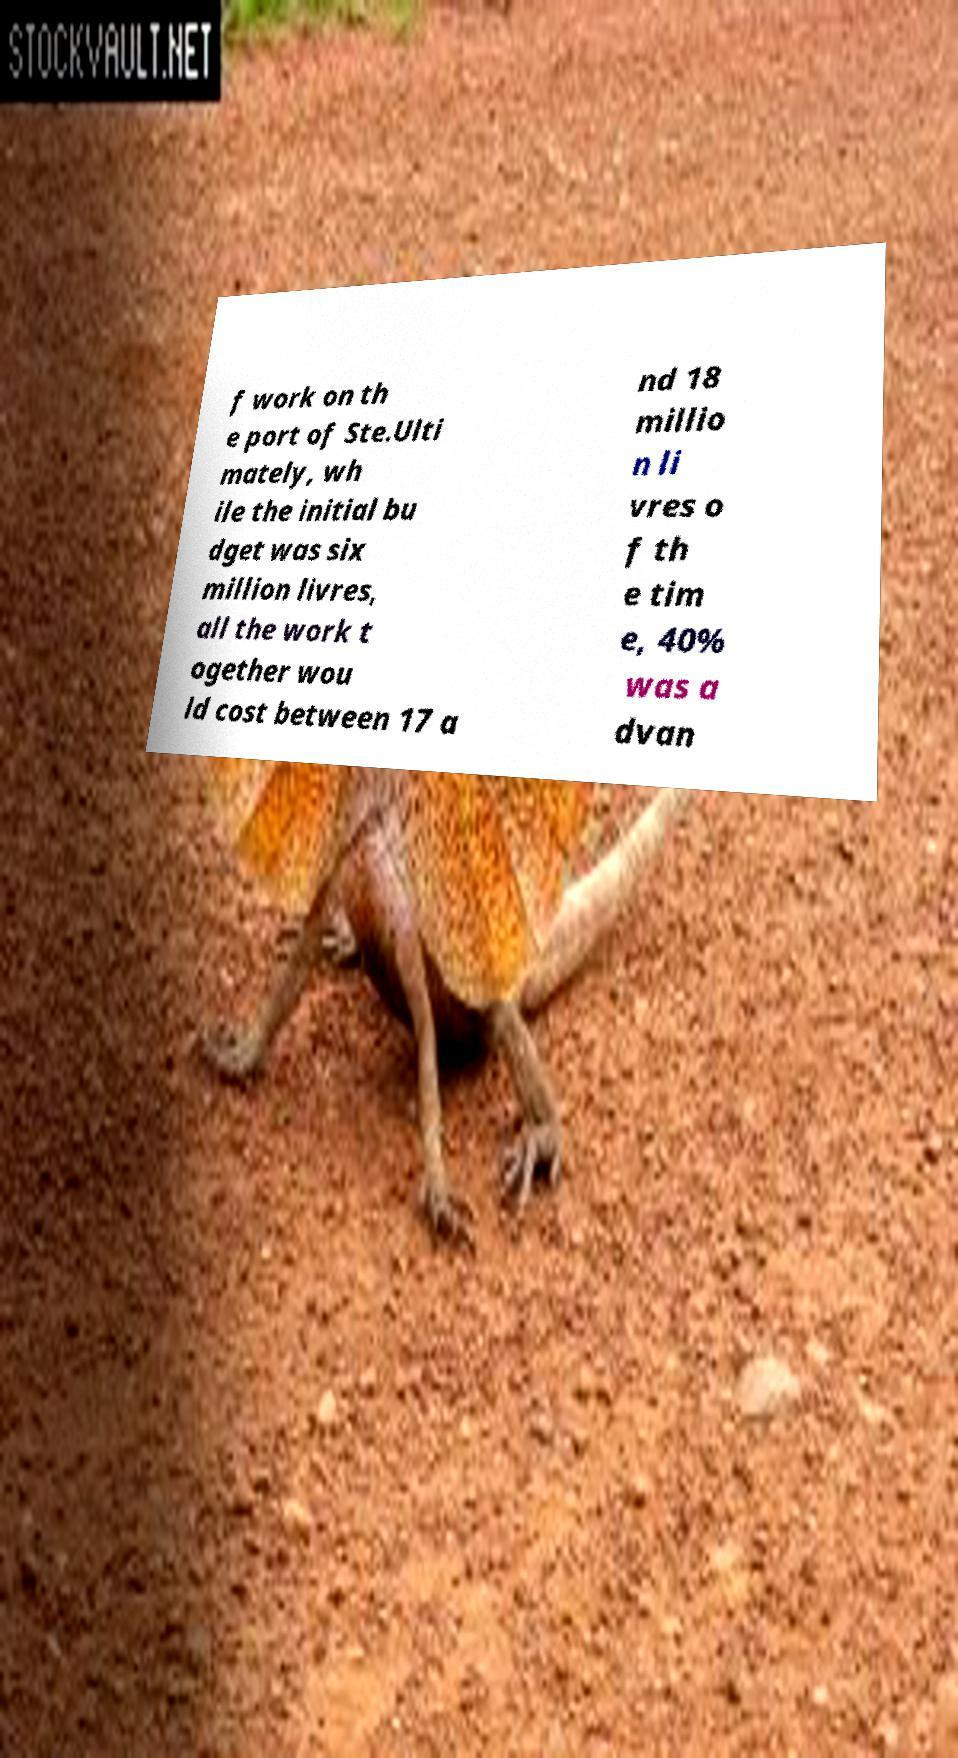For documentation purposes, I need the text within this image transcribed. Could you provide that? f work on th e port of Ste.Ulti mately, wh ile the initial bu dget was six million livres, all the work t ogether wou ld cost between 17 a nd 18 millio n li vres o f th e tim e, 40% was a dvan 